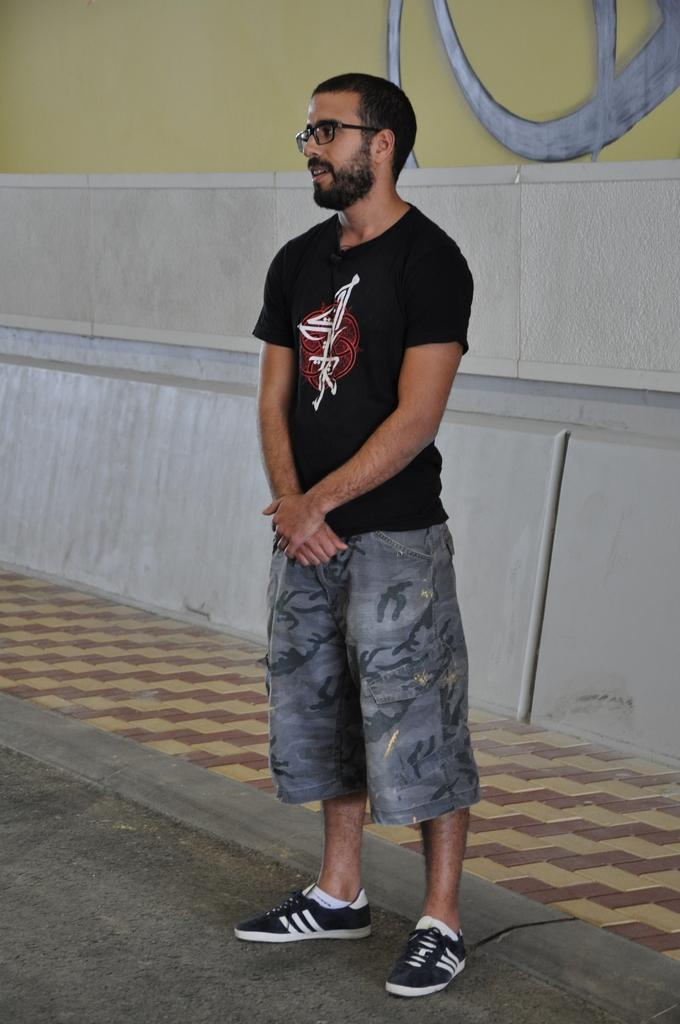What are the people in the image doing? The persons in the image are standing on the road. What can be seen in the background of the image? There is a wall in the background of the image. What type of stew is being prepared by the persons in the image? There is no indication in the image that any stew is being prepared, as the persons are standing on the road and there is no visible kitchen or cooking equipment. 